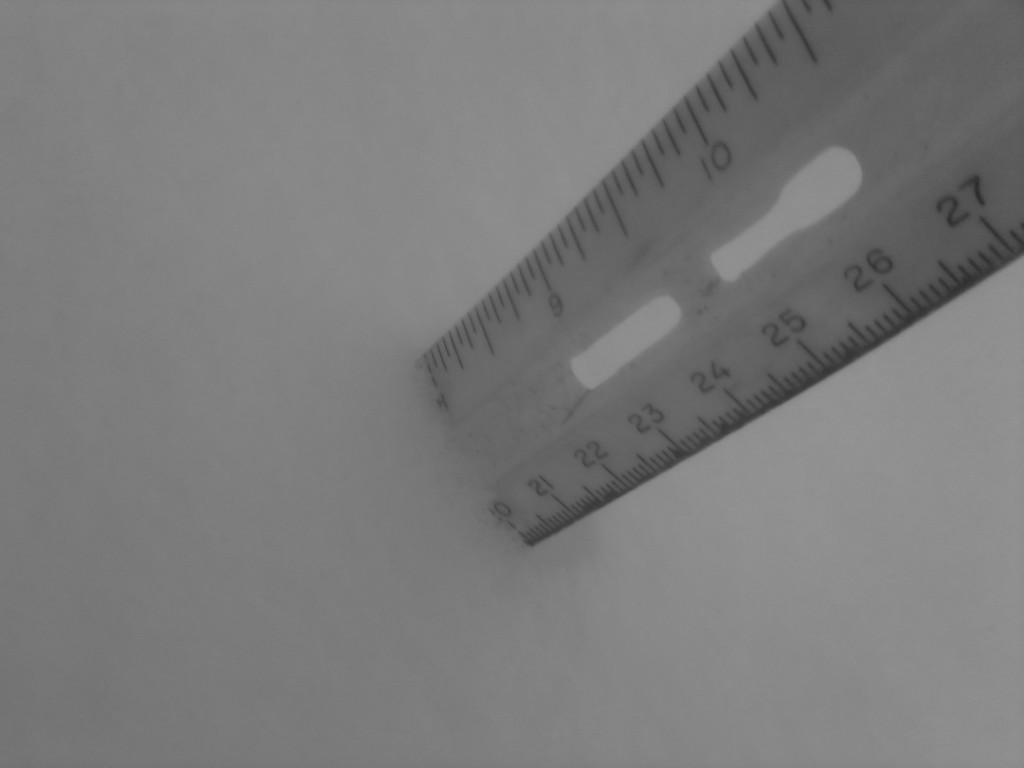Provide a one-sentence caption for the provided image. Ruler that ends at 10 standing upright on a platform. 